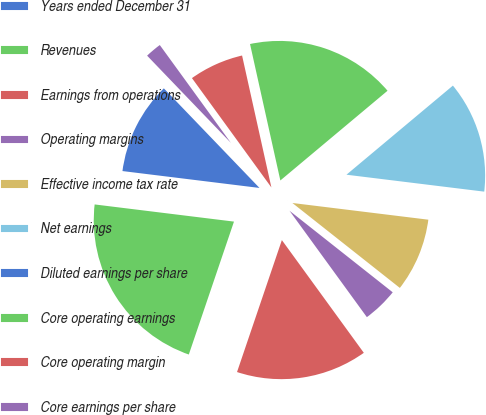<chart> <loc_0><loc_0><loc_500><loc_500><pie_chart><fcel>Years ended December 31<fcel>Revenues<fcel>Earnings from operations<fcel>Operating margins<fcel>Effective income tax rate<fcel>Net earnings<fcel>Diluted earnings per share<fcel>Core operating earnings<fcel>Core operating margin<fcel>Core earnings per share<nl><fcel>10.87%<fcel>21.74%<fcel>15.22%<fcel>4.35%<fcel>8.7%<fcel>13.04%<fcel>0.0%<fcel>17.39%<fcel>6.52%<fcel>2.18%<nl></chart> 